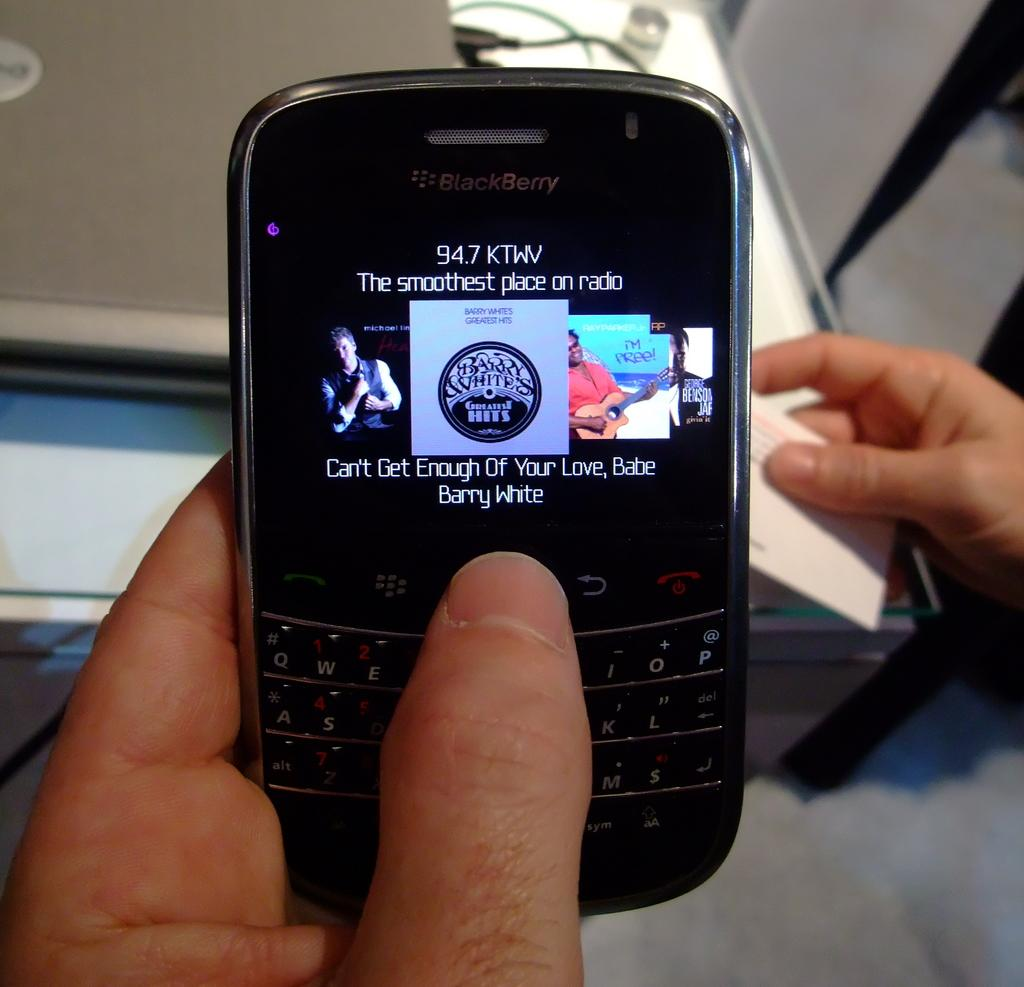Provide a one-sentence caption for the provided image. Someone searching through their music list on their blackberry. 